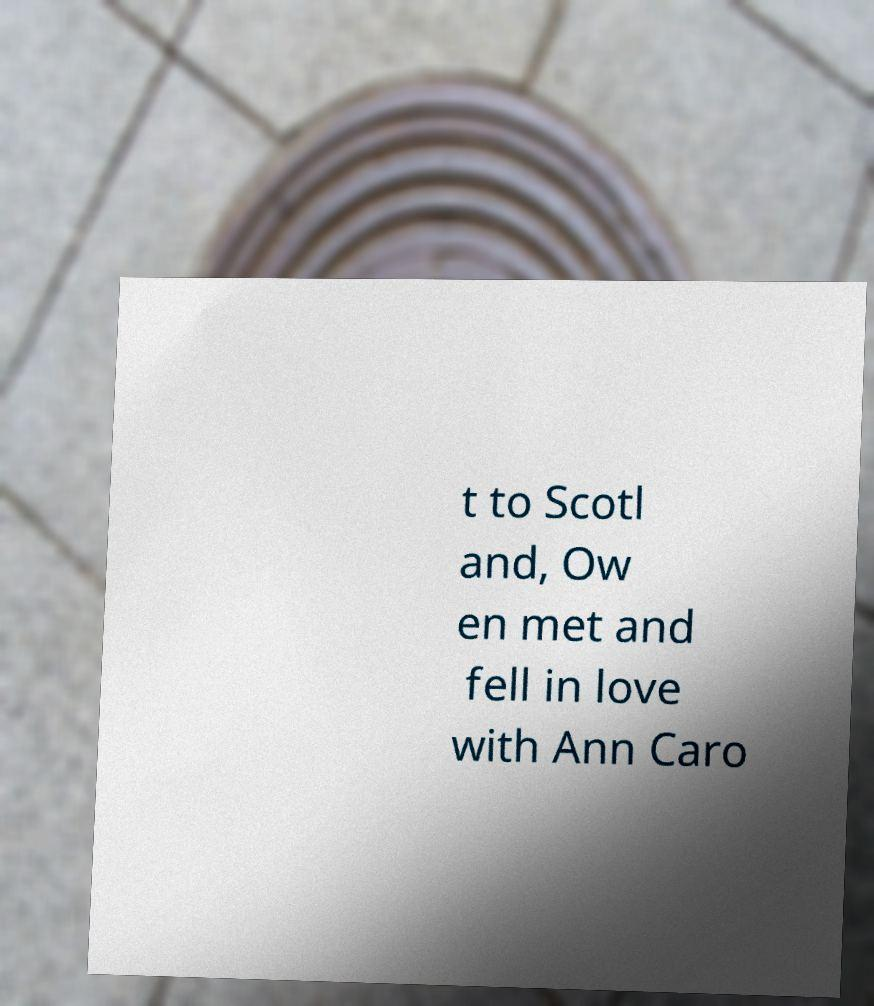Could you extract and type out the text from this image? t to Scotl and, Ow en met and fell in love with Ann Caro 